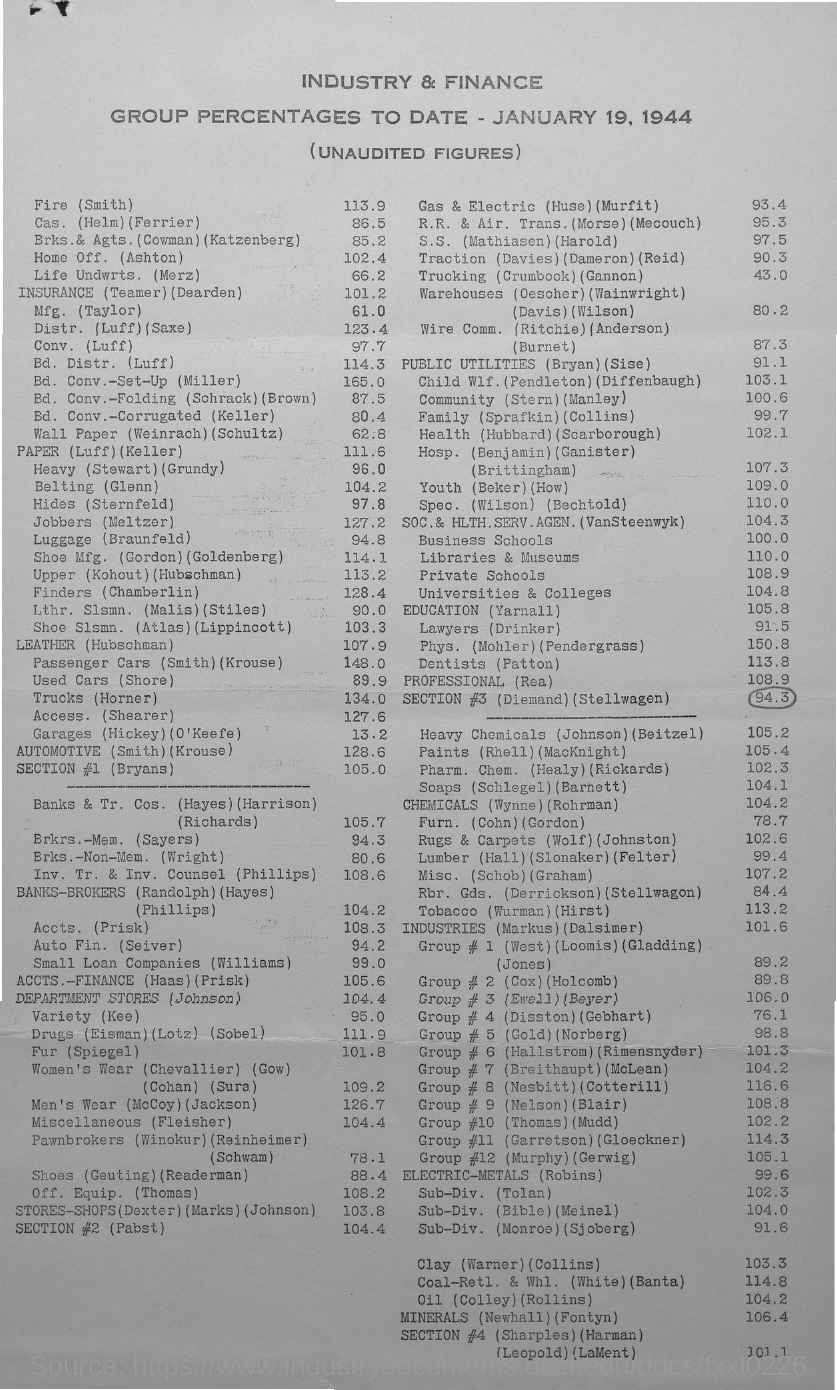What is the date mentioned in the document?
Offer a very short reply. JANUARY 19, 1944. What is the group percentage of Fire (Smith)?
Your answer should be compact. 113.9. What is the group percentage of Luggage (Braunfeld)?
Provide a succinct answer. 94.8. What is the group percentage of Trucks (Horner)?
Your answer should be compact. 134.0. 